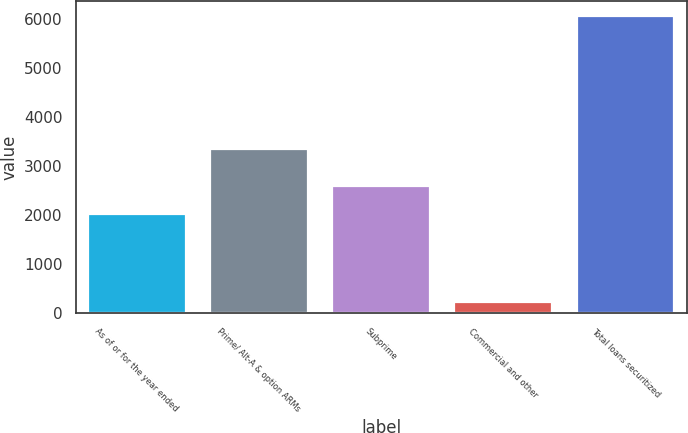<chart> <loc_0><loc_0><loc_500><loc_500><bar_chart><fcel>As of or for the year ended<fcel>Prime/ Alt-A & option ARMs<fcel>Subprime<fcel>Commercial and other<fcel>Total loans securitized<nl><fcel>2018<fcel>3354<fcel>2601.2<fcel>225<fcel>6057<nl></chart> 